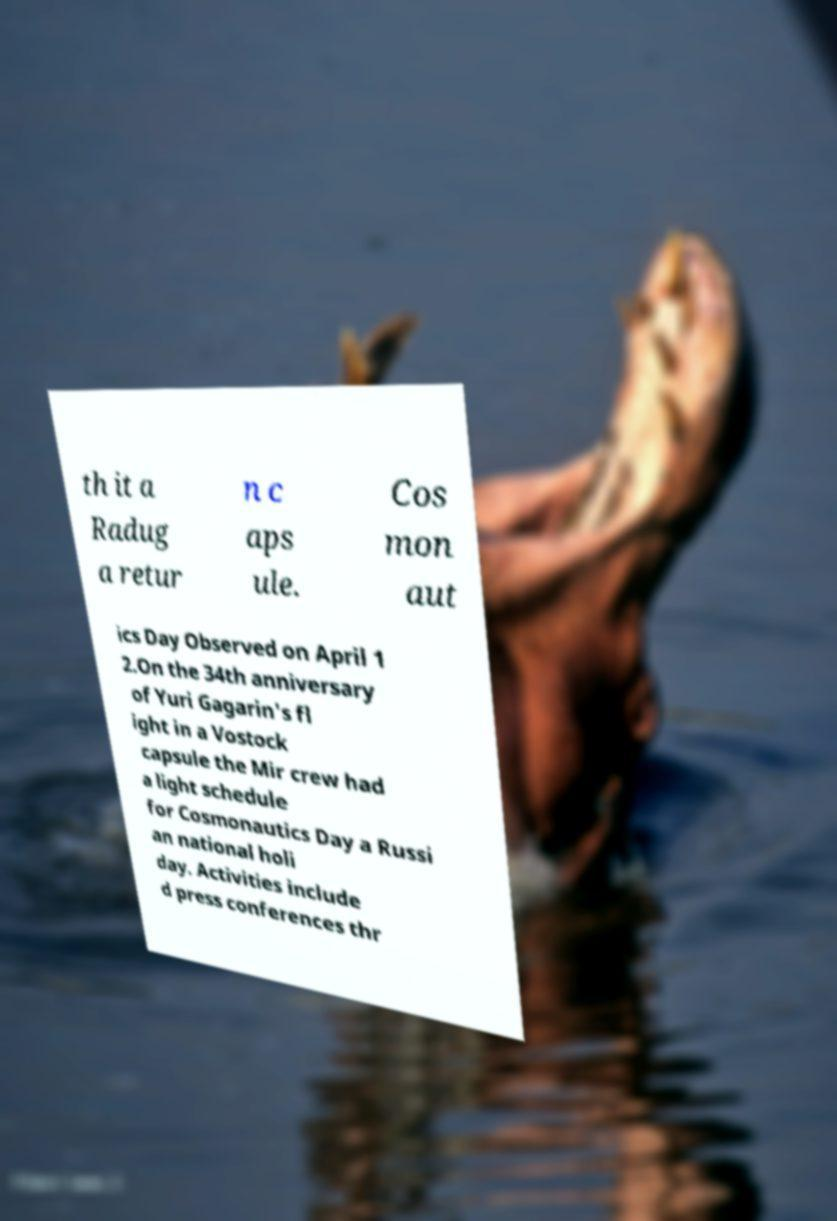Can you accurately transcribe the text from the provided image for me? th it a Radug a retur n c aps ule. Cos mon aut ics Day Observed on April 1 2.On the 34th anniversary of Yuri Gagarin's fl ight in a Vostock capsule the Mir crew had a light schedule for Cosmonautics Day a Russi an national holi day. Activities include d press conferences thr 